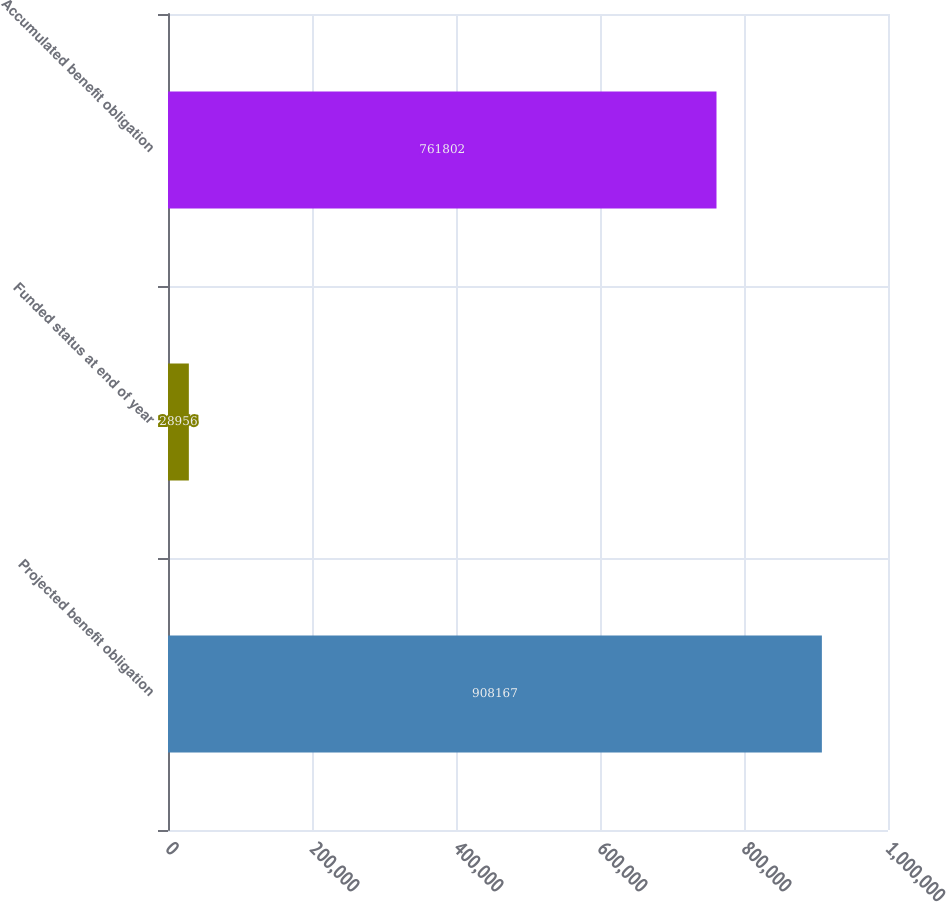<chart> <loc_0><loc_0><loc_500><loc_500><bar_chart><fcel>Projected benefit obligation<fcel>Funded status at end of year<fcel>Accumulated benefit obligation<nl><fcel>908167<fcel>28956<fcel>761802<nl></chart> 